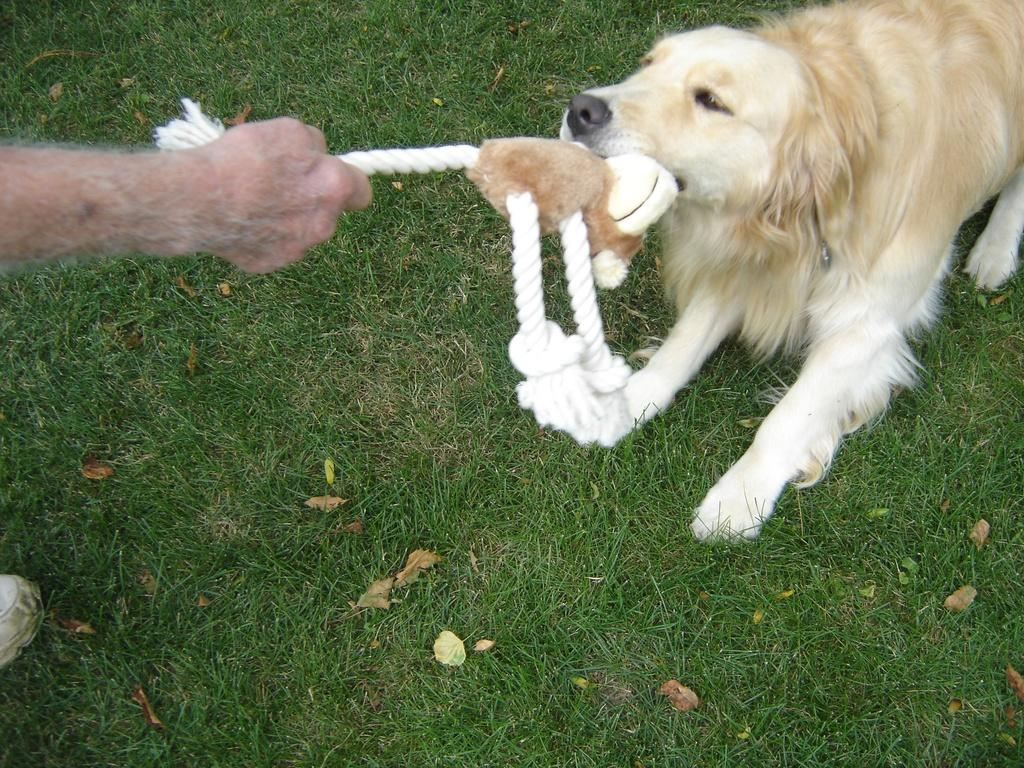What type of vegetation covers the land in the image? The land in the image is covered with grass. Can you describe the people in the image? There is a person in the image. What other living creature is present in the image? There is a dog in the image. What is the dog doing in the image? The dog is holding a toy. What type of fish can be seen swimming in the image? There is no fish present in the image. What type of meal is being prepared in the image? There is no meal preparation visible in the image. 